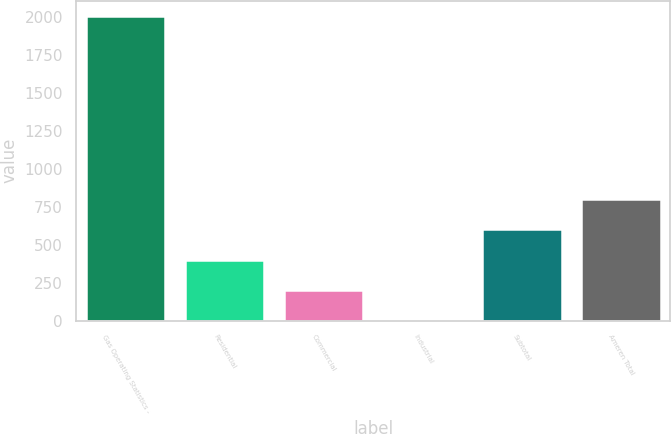Convert chart. <chart><loc_0><loc_0><loc_500><loc_500><bar_chart><fcel>Gas Operating Statistics -<fcel>Residential<fcel>Commercial<fcel>Industrial<fcel>Subtotal<fcel>Ameren Total<nl><fcel>2006<fcel>402<fcel>201.5<fcel>1<fcel>602.5<fcel>803<nl></chart> 